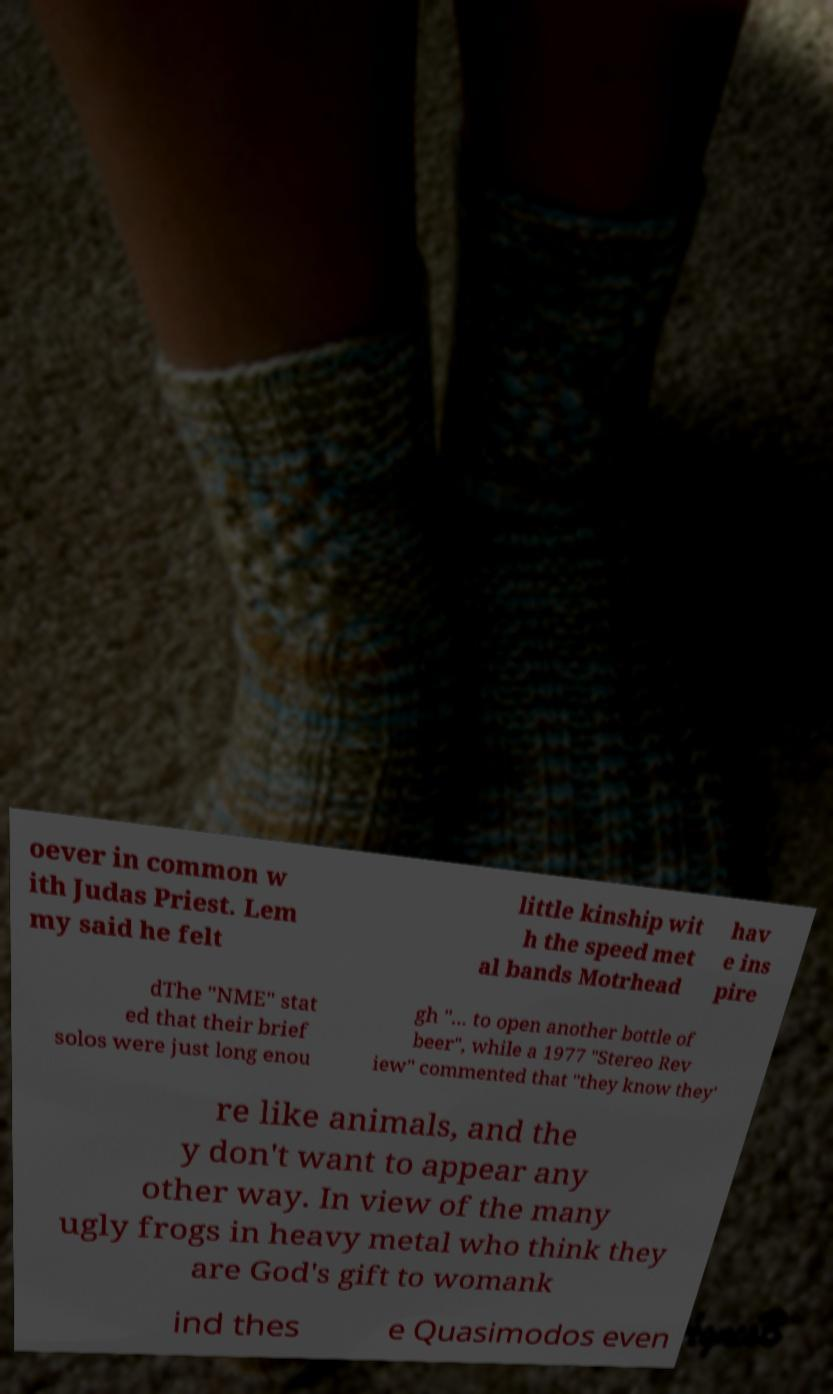Please identify and transcribe the text found in this image. oever in common w ith Judas Priest. Lem my said he felt little kinship wit h the speed met al bands Motrhead hav e ins pire dThe "NME" stat ed that their brief solos were just long enou gh "... to open another bottle of beer", while a 1977 "Stereo Rev iew" commented that "they know they' re like animals, and the y don't want to appear any other way. In view of the many ugly frogs in heavy metal who think they are God's gift to womank ind thes e Quasimodos even 